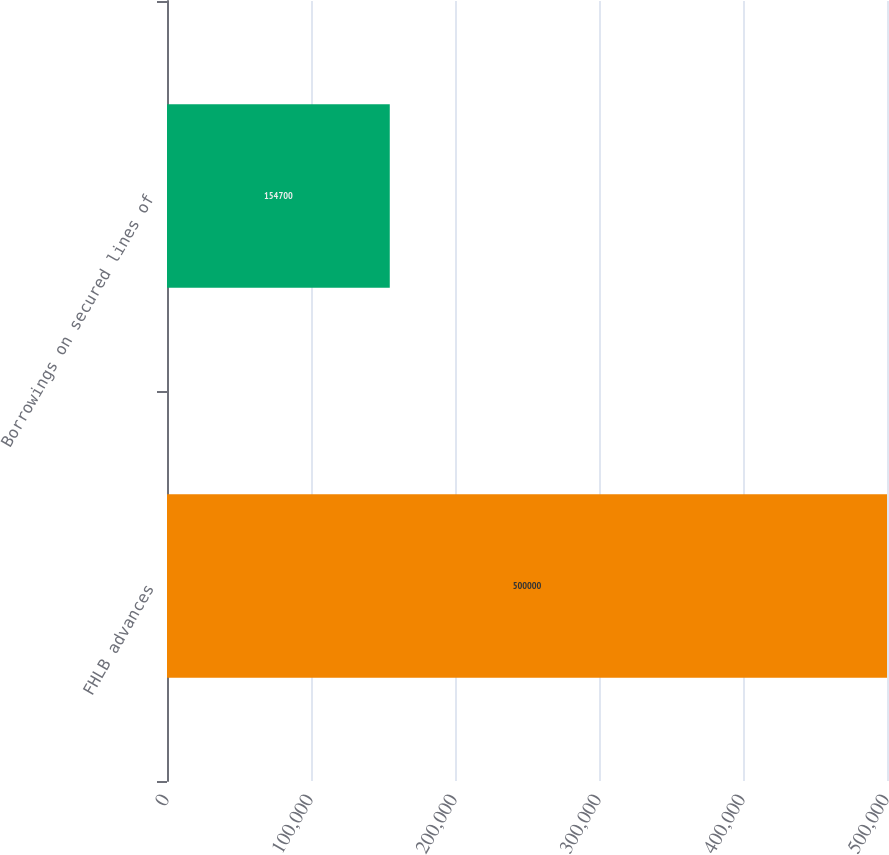<chart> <loc_0><loc_0><loc_500><loc_500><bar_chart><fcel>FHLB advances<fcel>Borrowings on secured lines of<nl><fcel>500000<fcel>154700<nl></chart> 